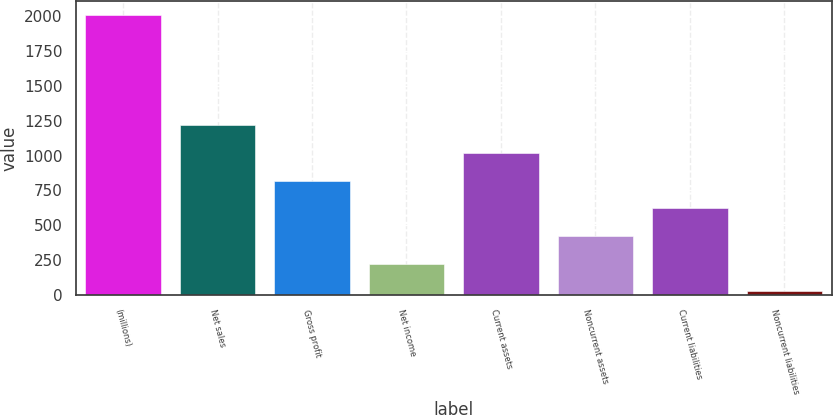Convert chart. <chart><loc_0><loc_0><loc_500><loc_500><bar_chart><fcel>(millions)<fcel>Net sales<fcel>Gross profit<fcel>Net income<fcel>Current assets<fcel>Noncurrent assets<fcel>Current liabilities<fcel>Noncurrent liabilities<nl><fcel>2010<fcel>1216.6<fcel>819.9<fcel>224.85<fcel>1018.25<fcel>423.2<fcel>621.55<fcel>26.5<nl></chart> 